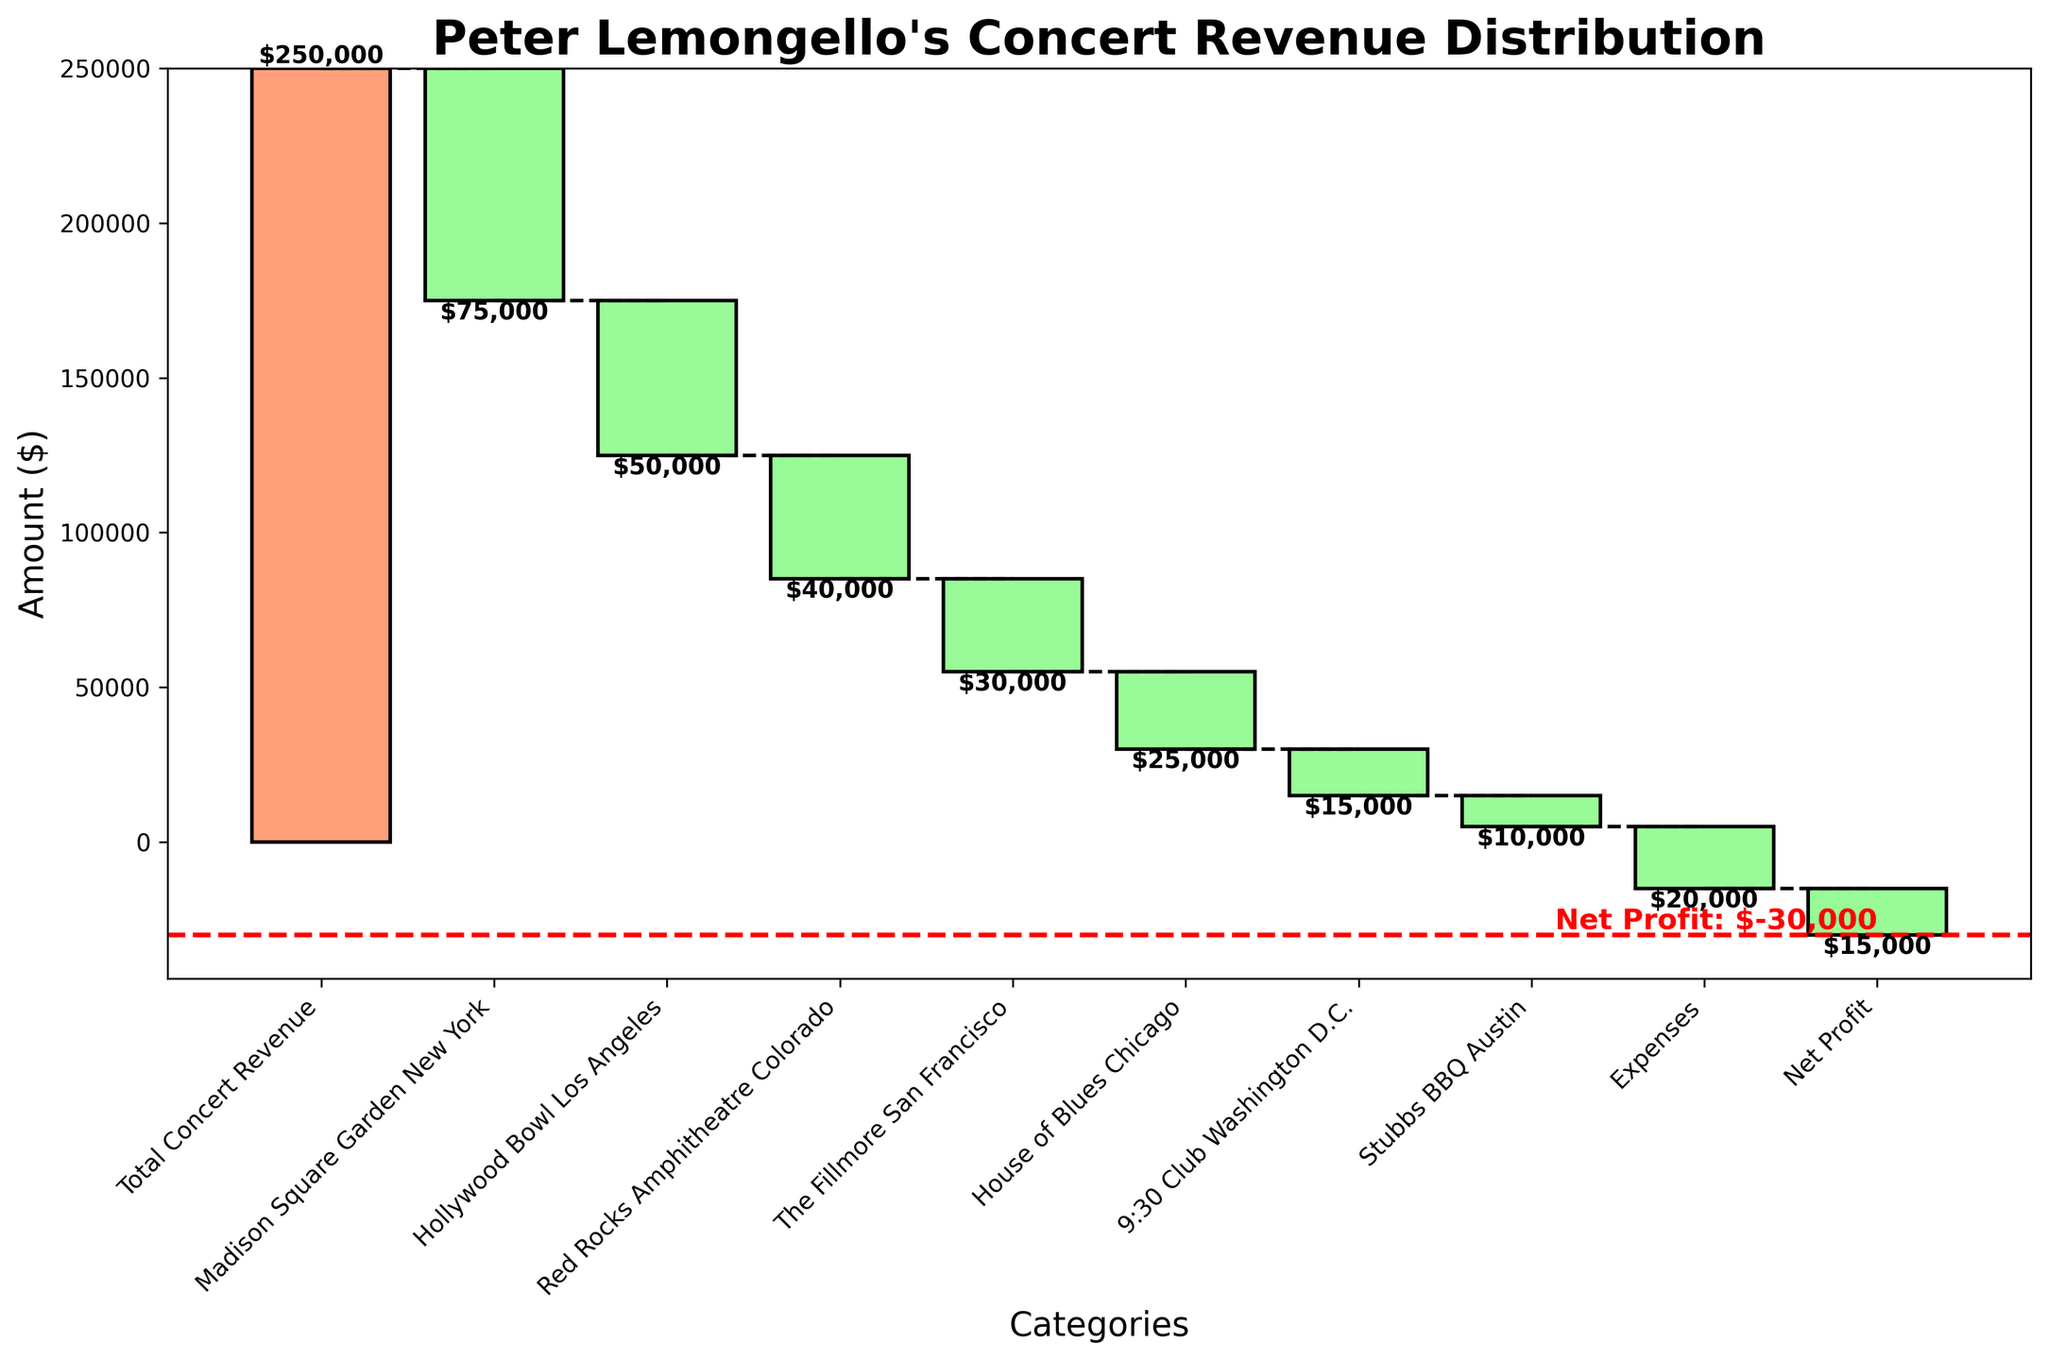What is the total concert revenue? The total concert revenue is labeled as the first category in the chart. The bar associated with "Total Concert Revenue" shows an amount of $250,000.
Answer: $250,000 Which venue has the smallest negative impact on revenue? The smallest negative impact can be identified by finding the bar with the smallest downward value. "Stubbs BBQ Austin" shows a negative impact of -$10,000, which is the smallest among the venues.
Answer: Stubbs BBQ Austin What is the revenue amount lost at Madison Square Garden New York? The revenue lost at Madison Square Garden New York is visualized by a downward bar with the value labeled. The label indicates a loss of -$75,000.
Answer: -$75,000 What is the combined negative revenue impact of Hollywood Bowl Los Angeles and Red Rocks Amphitheatre Colorado? Adding the negative impacts of both venues: -$50,000 (Hollywood Bowl Los Angeles) and -$40,000 (Red Rocks Amphitheatre Colorado), the combined impact is -$90,000.
Answer: -$90,000 Which category has the largest negative impact on the overall revenue? The venue with the largest negative downward bar represents the largest negative impact. "Madison Square Garden New York" shows a loss of -$75,000, which is the largest negative value.
Answer: Madison Square Garden New York What is the net profit from the concerts? At the end of the Waterfall Chart, the Net Profit is indicated by a red line and label. The net profit is shown to be -$15,000.
Answer: -$15,000 How much revenue was lost in Washington D.C.? The 9:30 Club Washington D.C. venue’s impact is shown in the chart with a downward bar labeled as -$15,000.
Answer: -$15,000 What is the sum of negative revenue impacts from The Fillmore San Francisco and House of Blues Chicago? Adding the negative impacts of these two venues: -$30,000 (The Fillmore San Francisco) and -$25,000 (House of Blues Chicago), the sum is -$55,000.
Answer: -$55,000 What is the difference between total concert revenue and net profit? The difference between $250,000 (Total Concert Revenue) and -$15,000 (Net Profit) is calculated as $250,000 - (-$15,000) = $250,000 + $15,000 = $235,000.
Answer: $235,000 Which category represents expenses in the chart and what is the amount? The "Expenses" category is labeled in the chart and shows a downward bar with an amount of -$20,000.
Answer: -$20,000 